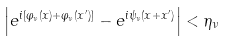<formula> <loc_0><loc_0><loc_500><loc_500>\left | e ^ { i [ \varphi _ { \nu } ( x ) + \varphi _ { \nu } ( x ^ { \prime } ) ] } - e ^ { i \psi _ { \nu } ( x + x ^ { \prime } ) } \right | < \eta _ { \nu }</formula> 